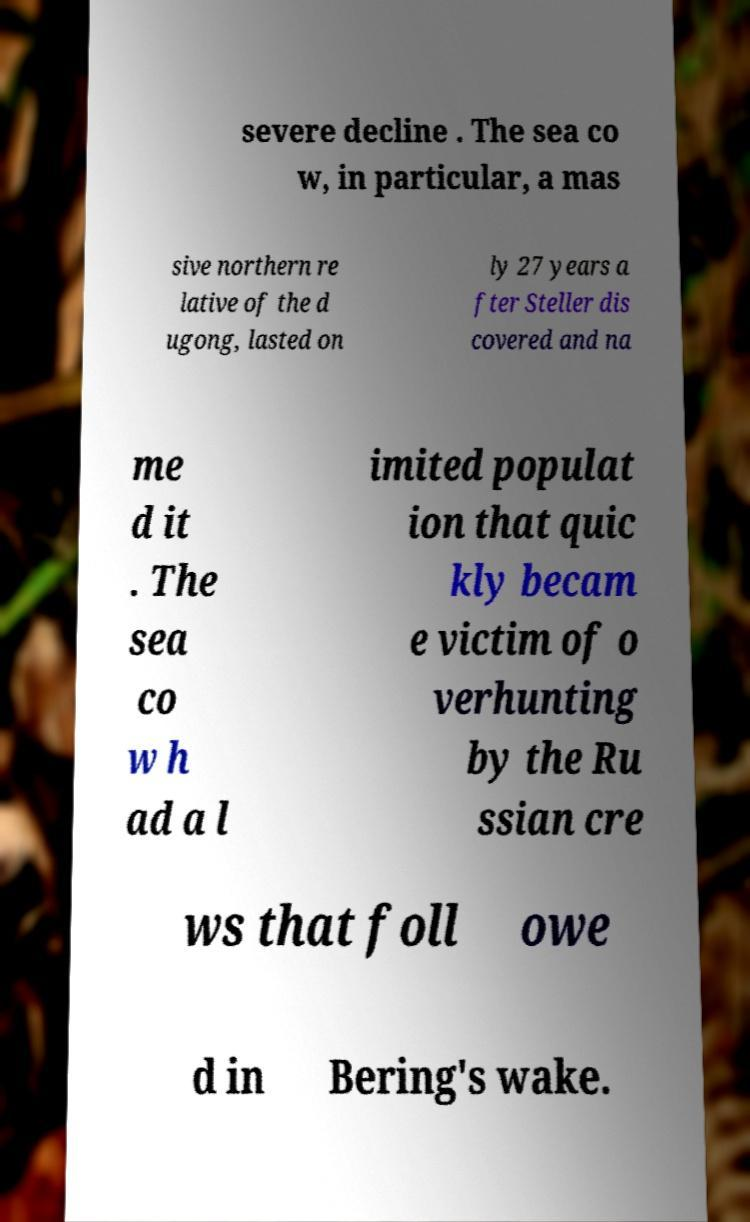Please identify and transcribe the text found in this image. severe decline . The sea co w, in particular, a mas sive northern re lative of the d ugong, lasted on ly 27 years a fter Steller dis covered and na me d it . The sea co w h ad a l imited populat ion that quic kly becam e victim of o verhunting by the Ru ssian cre ws that foll owe d in Bering's wake. 